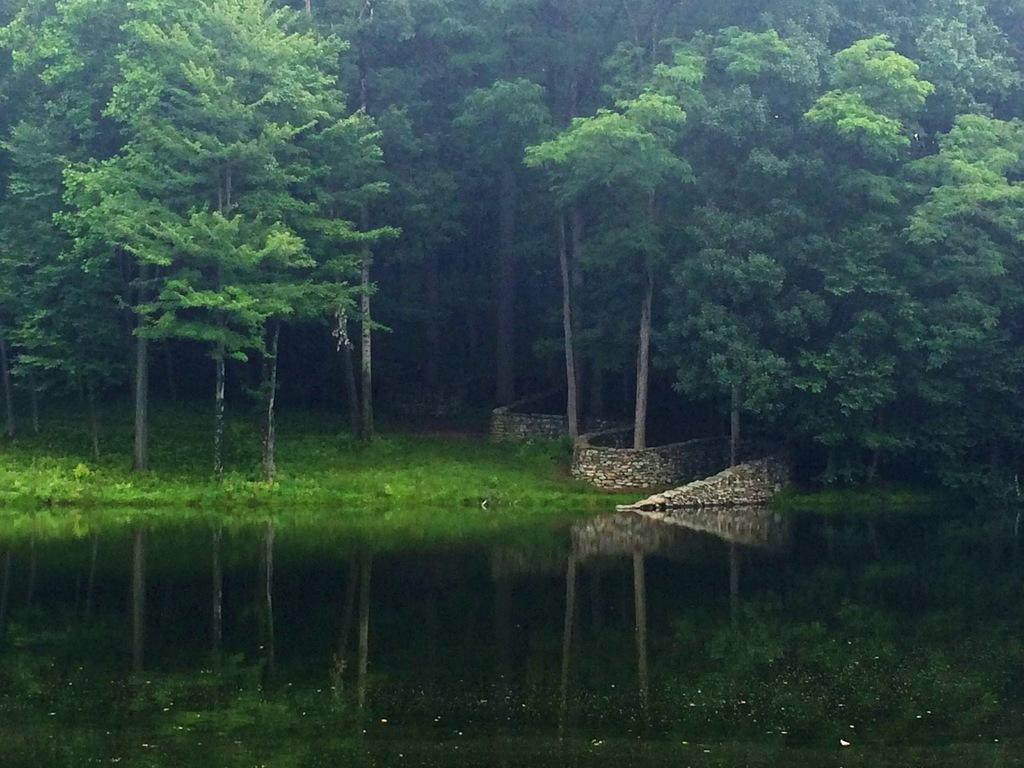What is at the bottom of the image? There is water at the bottom of the image. What type of vegetation is present near the water? There is grass on the ground behind the water. What type of structure can be seen in the image? There is a stone wall in the image. What can be seen in the distance in the image? There are many trees in the background of the image. How many snakes are slithering through the grass in the image? There are no snakes present in the image. What team is responsible for maintaining the stone wall in the image? There is no indication of a team responsible for the stone wall in the image. 